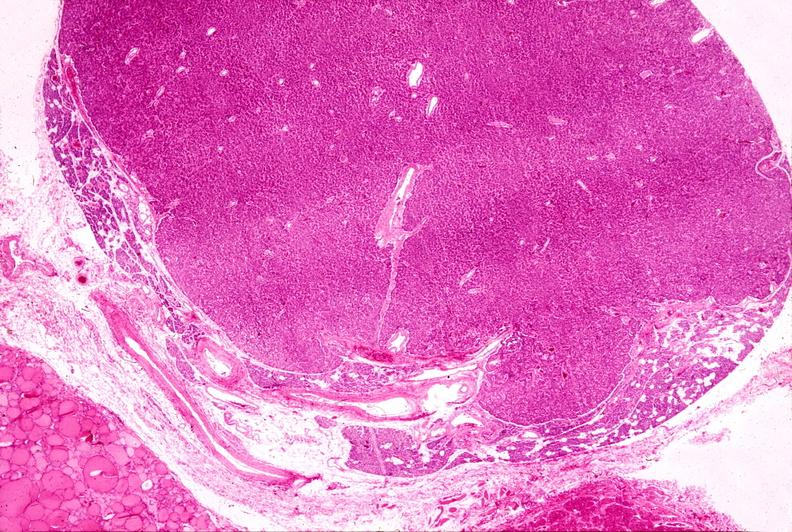s sacrococcygeal teratoma present?
Answer the question using a single word or phrase. No 